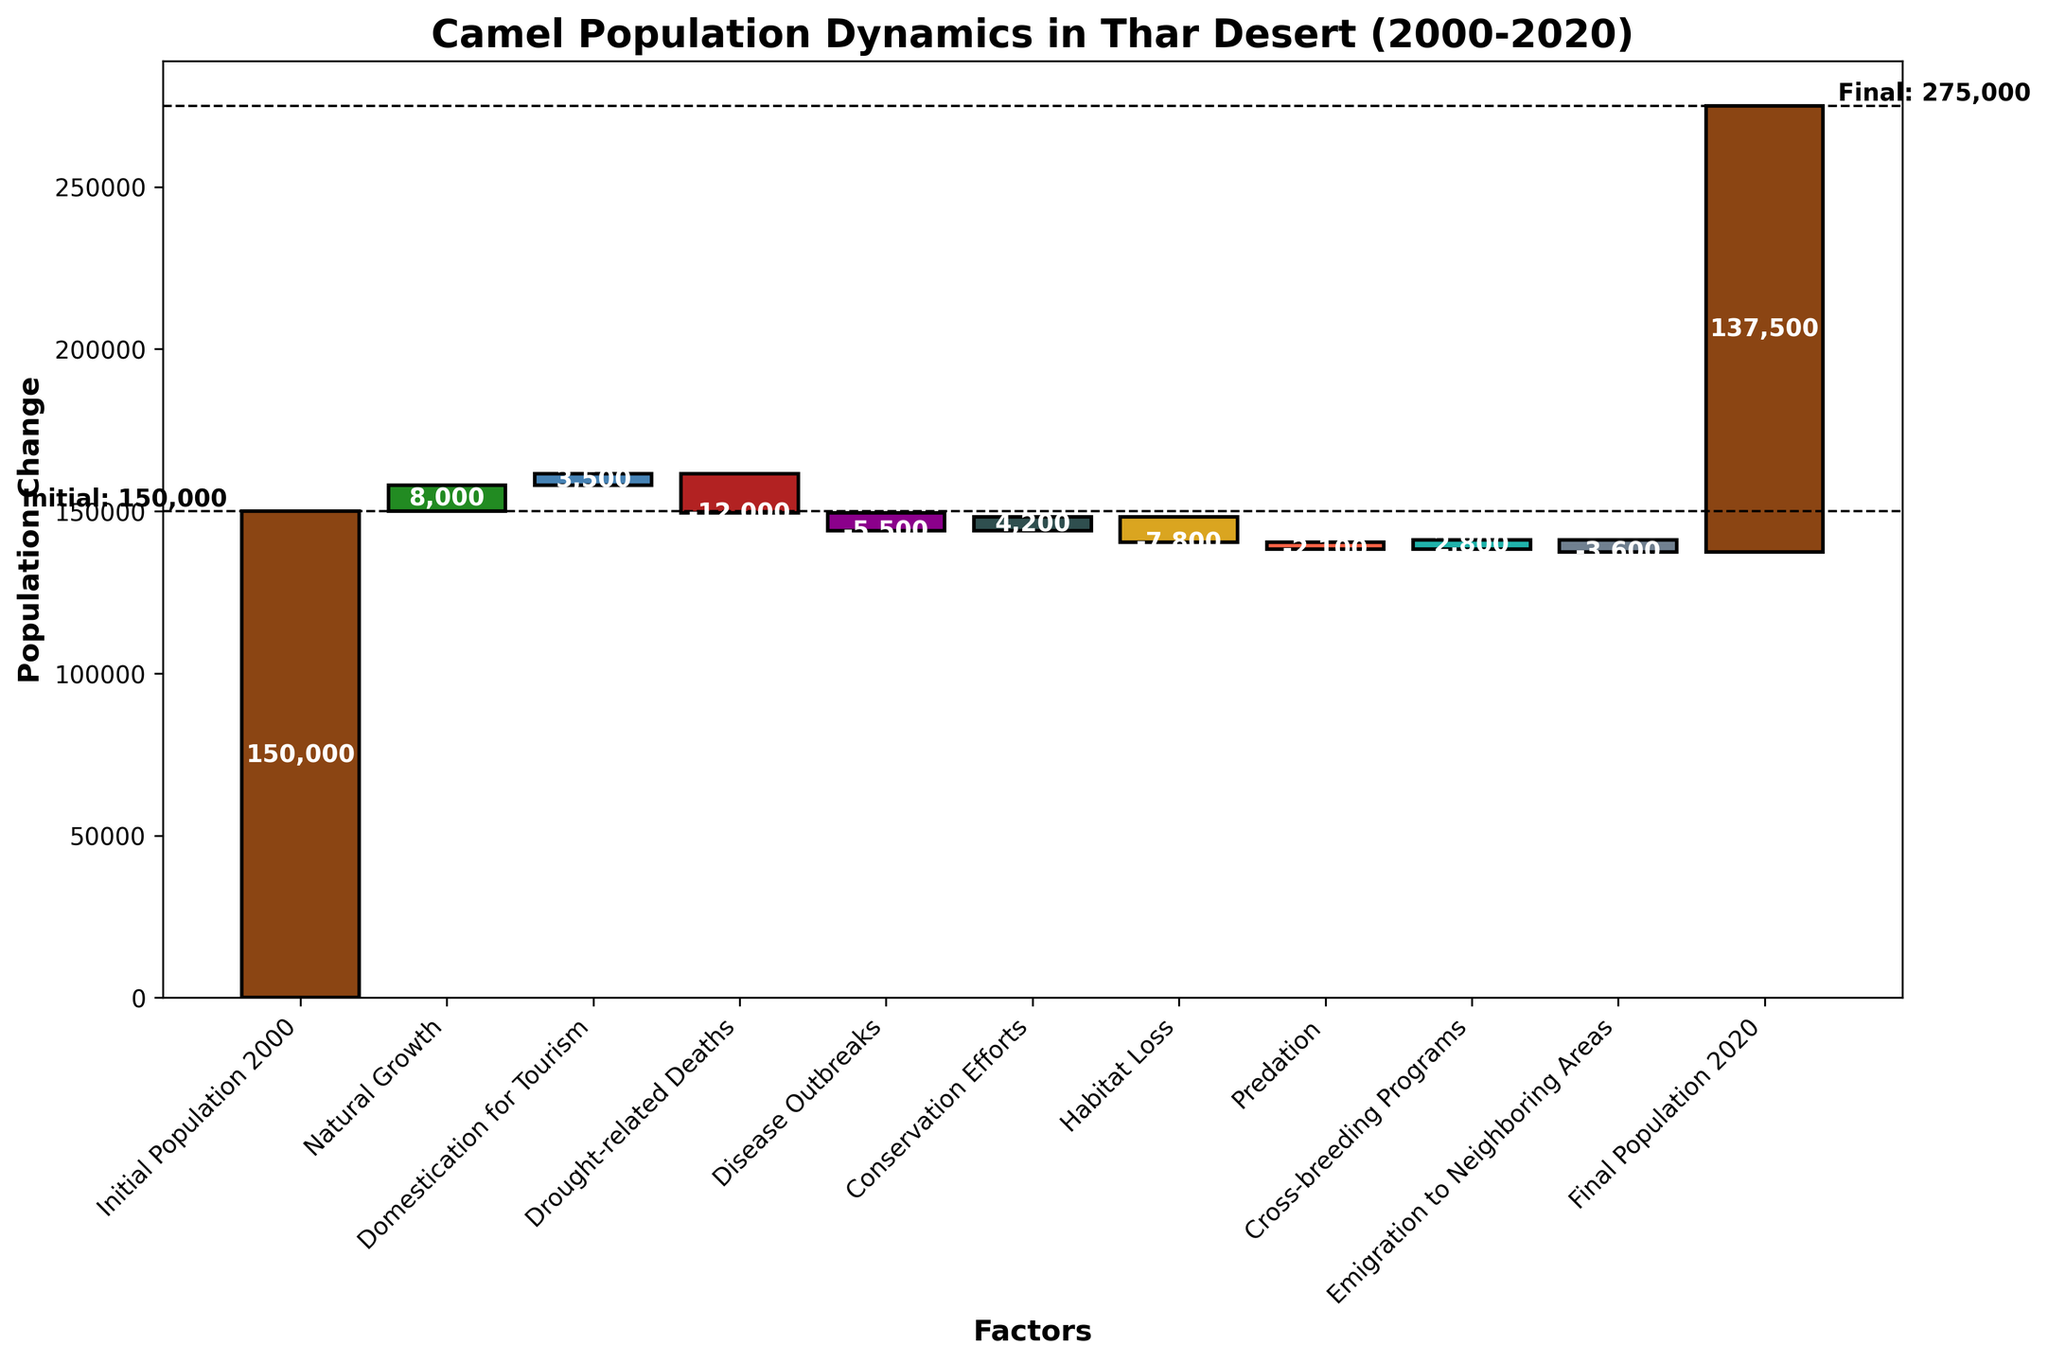What is the title of the chart? The title of the chart is typically found at the top of the figure. It provides a brief description of what the figure is about. In this case, it's "Camel Population Dynamics in Thar Desert (2000-2020)."
Answer: Camel Population Dynamics in Thar Desert (2000-2020) How many categories are displayed in the chart? By counting the distinct segments or bars in the waterfall chart, we can see that there are 11 categories listed.
Answer: 11 Which factor contributed the most to the decline in camel population? By examining the bars that show a decrease and finding the one with the largest negative value, it is evident that "Drought-related Deaths" had the most significant decline at -12,000.
Answer: Drought-related Deaths What is the net change in the camel population between 2000 and 2020? To find the net change, we need to subtract the initial population from the final population. The initial population is 150,000 and the final population is 137,500. Hence, the net change is 137,500 - 150,000 = -12,500.
Answer: -12,500 Which two factors contributed positively towards the camel population growth the most? By looking at the positive factors contributing to growth, the largest positive changes are from "Natural Growth" (8,000) and "Domestication for Tourism" (3,500).
Answer: Natural Growth and Domestication for Tourism How many factors resulted in a decline in the camel population? By counting the bars or segments that have negative values in the waterfall chart, one can see there are five such factors: "Drought-related Deaths," "Disease Outbreaks," "Habitat Loss," "Predation," and "Emigration to Neighboring Areas."
Answer: 5 What is the overall contribution of conservation efforts and cross-breeding programs combined? Adding the values of "Conservation Efforts" (4,200) and "Cross-breeding Programs" (2,800) gives us 4,200 + 2,800 = 7,000.
Answer: 7,000 Is the final camel population greater than 137,000? The final population is given in the chart as 137,500. Since 137,500 is greater than 137,000, the answer is yes.
Answer: Yes How much did habitat loss decrease the camel population? The value corresponding to "Habitat Loss" is represented as a negative number, which is -7,800.
Answer: 7,800 What are the initial and final populations of camels depicted in the chart? The initial population is displayed at the start of the chart, which is 150,000, and the final population is at the end, which is 137,500.
Answer: 150,000 and 137,500 